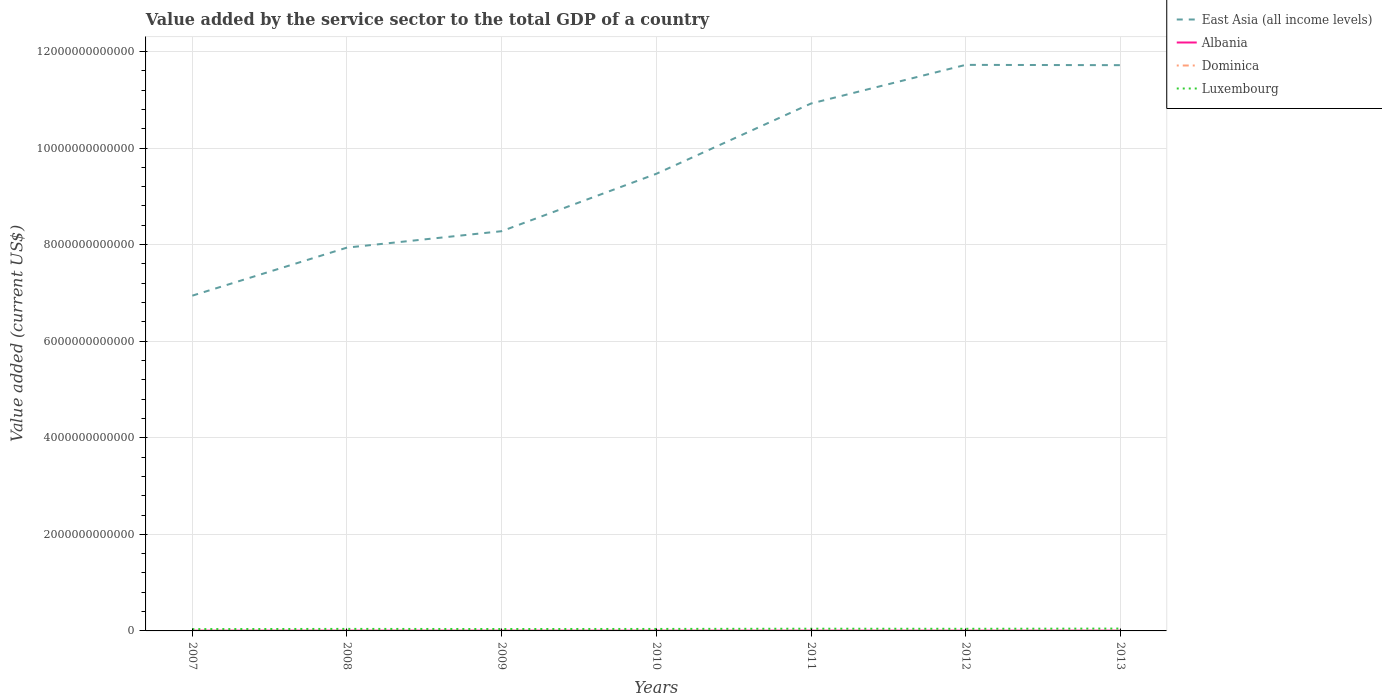Does the line corresponding to East Asia (all income levels) intersect with the line corresponding to Luxembourg?
Give a very brief answer. No. Is the number of lines equal to the number of legend labels?
Keep it short and to the point. Yes. Across all years, what is the maximum value added by the service sector to the total GDP in Dominica?
Offer a terse response. 2.46e+08. What is the total value added by the service sector to the total GDP in Luxembourg in the graph?
Offer a very short reply. -3.57e+09. What is the difference between the highest and the second highest value added by the service sector to the total GDP in Albania?
Offer a terse response. 7.05e+08. What is the difference between the highest and the lowest value added by the service sector to the total GDP in Albania?
Your answer should be very brief. 4. What is the difference between two consecutive major ticks on the Y-axis?
Your answer should be compact. 2.00e+12. How are the legend labels stacked?
Make the answer very short. Vertical. What is the title of the graph?
Provide a succinct answer. Value added by the service sector to the total GDP of a country. Does "St. Kitts and Nevis" appear as one of the legend labels in the graph?
Make the answer very short. No. What is the label or title of the Y-axis?
Ensure brevity in your answer.  Value added (current US$). What is the Value added (current US$) in East Asia (all income levels) in 2007?
Offer a very short reply. 6.94e+12. What is the Value added (current US$) in Albania in 2007?
Offer a terse response. 5.05e+09. What is the Value added (current US$) of Dominica in 2007?
Give a very brief answer. 2.46e+08. What is the Value added (current US$) of Luxembourg in 2007?
Keep it short and to the point. 3.75e+1. What is the Value added (current US$) in East Asia (all income levels) in 2008?
Your response must be concise. 7.94e+12. What is the Value added (current US$) in Albania in 2008?
Give a very brief answer. 5.76e+09. What is the Value added (current US$) of Dominica in 2008?
Keep it short and to the point. 2.65e+08. What is the Value added (current US$) in Luxembourg in 2008?
Keep it short and to the point. 4.19e+1. What is the Value added (current US$) of East Asia (all income levels) in 2009?
Keep it short and to the point. 8.28e+12. What is the Value added (current US$) in Albania in 2009?
Offer a very short reply. 5.46e+09. What is the Value added (current US$) in Dominica in 2009?
Offer a terse response. 2.86e+08. What is the Value added (current US$) of Luxembourg in 2009?
Your answer should be very brief. 3.93e+1. What is the Value added (current US$) of East Asia (all income levels) in 2010?
Your answer should be very brief. 9.47e+12. What is the Value added (current US$) of Albania in 2010?
Your answer should be compact. 5.25e+09. What is the Value added (current US$) of Dominica in 2010?
Provide a short and direct response. 2.93e+08. What is the Value added (current US$) in Luxembourg in 2010?
Your answer should be compact. 4.10e+1. What is the Value added (current US$) in East Asia (all income levels) in 2011?
Ensure brevity in your answer.  1.09e+13. What is the Value added (current US$) in Albania in 2011?
Provide a short and direct response. 5.71e+09. What is the Value added (current US$) of Dominica in 2011?
Your answer should be compact. 2.91e+08. What is the Value added (current US$) in Luxembourg in 2011?
Ensure brevity in your answer.  4.59e+1. What is the Value added (current US$) of East Asia (all income levels) in 2012?
Offer a terse response. 1.17e+13. What is the Value added (current US$) of Albania in 2012?
Ensure brevity in your answer.  5.54e+09. What is the Value added (current US$) in Dominica in 2012?
Offer a terse response. 2.85e+08. What is the Value added (current US$) of Luxembourg in 2012?
Offer a terse response. 4.39e+1. What is the Value added (current US$) of East Asia (all income levels) in 2013?
Provide a succinct answer. 1.17e+13. What is the Value added (current US$) in Albania in 2013?
Your answer should be very brief. 5.70e+09. What is the Value added (current US$) of Dominica in 2013?
Ensure brevity in your answer.  2.97e+08. What is the Value added (current US$) of Luxembourg in 2013?
Provide a succinct answer. 4.88e+1. Across all years, what is the maximum Value added (current US$) in East Asia (all income levels)?
Provide a succinct answer. 1.17e+13. Across all years, what is the maximum Value added (current US$) in Albania?
Offer a very short reply. 5.76e+09. Across all years, what is the maximum Value added (current US$) in Dominica?
Give a very brief answer. 2.97e+08. Across all years, what is the maximum Value added (current US$) of Luxembourg?
Provide a succinct answer. 4.88e+1. Across all years, what is the minimum Value added (current US$) of East Asia (all income levels)?
Provide a short and direct response. 6.94e+12. Across all years, what is the minimum Value added (current US$) in Albania?
Make the answer very short. 5.05e+09. Across all years, what is the minimum Value added (current US$) of Dominica?
Ensure brevity in your answer.  2.46e+08. Across all years, what is the minimum Value added (current US$) of Luxembourg?
Offer a very short reply. 3.75e+1. What is the total Value added (current US$) of East Asia (all income levels) in the graph?
Ensure brevity in your answer.  6.70e+13. What is the total Value added (current US$) of Albania in the graph?
Offer a very short reply. 3.85e+1. What is the total Value added (current US$) of Dominica in the graph?
Keep it short and to the point. 1.96e+09. What is the total Value added (current US$) of Luxembourg in the graph?
Offer a terse response. 2.98e+11. What is the difference between the Value added (current US$) of East Asia (all income levels) in 2007 and that in 2008?
Offer a very short reply. -9.95e+11. What is the difference between the Value added (current US$) in Albania in 2007 and that in 2008?
Your response must be concise. -7.05e+08. What is the difference between the Value added (current US$) in Dominica in 2007 and that in 2008?
Provide a succinct answer. -1.88e+07. What is the difference between the Value added (current US$) of Luxembourg in 2007 and that in 2008?
Offer a terse response. -4.41e+09. What is the difference between the Value added (current US$) in East Asia (all income levels) in 2007 and that in 2009?
Offer a terse response. -1.34e+12. What is the difference between the Value added (current US$) of Albania in 2007 and that in 2009?
Offer a terse response. -4.05e+08. What is the difference between the Value added (current US$) in Dominica in 2007 and that in 2009?
Provide a succinct answer. -4.00e+07. What is the difference between the Value added (current US$) in Luxembourg in 2007 and that in 2009?
Provide a short and direct response. -1.84e+09. What is the difference between the Value added (current US$) of East Asia (all income levels) in 2007 and that in 2010?
Keep it short and to the point. -2.52e+12. What is the difference between the Value added (current US$) of Albania in 2007 and that in 2010?
Your answer should be very brief. -1.98e+08. What is the difference between the Value added (current US$) in Dominica in 2007 and that in 2010?
Keep it short and to the point. -4.67e+07. What is the difference between the Value added (current US$) of Luxembourg in 2007 and that in 2010?
Keep it short and to the point. -3.57e+09. What is the difference between the Value added (current US$) in East Asia (all income levels) in 2007 and that in 2011?
Offer a very short reply. -3.98e+12. What is the difference between the Value added (current US$) of Albania in 2007 and that in 2011?
Make the answer very short. -6.52e+08. What is the difference between the Value added (current US$) of Dominica in 2007 and that in 2011?
Give a very brief answer. -4.49e+07. What is the difference between the Value added (current US$) in Luxembourg in 2007 and that in 2011?
Offer a terse response. -8.43e+09. What is the difference between the Value added (current US$) in East Asia (all income levels) in 2007 and that in 2012?
Provide a short and direct response. -4.78e+12. What is the difference between the Value added (current US$) of Albania in 2007 and that in 2012?
Keep it short and to the point. -4.85e+08. What is the difference between the Value added (current US$) of Dominica in 2007 and that in 2012?
Your answer should be compact. -3.86e+07. What is the difference between the Value added (current US$) of Luxembourg in 2007 and that in 2012?
Ensure brevity in your answer.  -6.42e+09. What is the difference between the Value added (current US$) in East Asia (all income levels) in 2007 and that in 2013?
Offer a very short reply. -4.77e+12. What is the difference between the Value added (current US$) of Albania in 2007 and that in 2013?
Provide a succinct answer. -6.48e+08. What is the difference between the Value added (current US$) in Dominica in 2007 and that in 2013?
Give a very brief answer. -5.06e+07. What is the difference between the Value added (current US$) in Luxembourg in 2007 and that in 2013?
Ensure brevity in your answer.  -1.13e+1. What is the difference between the Value added (current US$) in East Asia (all income levels) in 2008 and that in 2009?
Make the answer very short. -3.40e+11. What is the difference between the Value added (current US$) of Albania in 2008 and that in 2009?
Make the answer very short. 3.00e+08. What is the difference between the Value added (current US$) in Dominica in 2008 and that in 2009?
Your answer should be very brief. -2.11e+07. What is the difference between the Value added (current US$) of Luxembourg in 2008 and that in 2009?
Your answer should be compact. 2.56e+09. What is the difference between the Value added (current US$) in East Asia (all income levels) in 2008 and that in 2010?
Your answer should be compact. -1.53e+12. What is the difference between the Value added (current US$) of Albania in 2008 and that in 2010?
Give a very brief answer. 5.07e+08. What is the difference between the Value added (current US$) in Dominica in 2008 and that in 2010?
Provide a short and direct response. -2.78e+07. What is the difference between the Value added (current US$) in Luxembourg in 2008 and that in 2010?
Give a very brief answer. 8.35e+08. What is the difference between the Value added (current US$) of East Asia (all income levels) in 2008 and that in 2011?
Keep it short and to the point. -2.98e+12. What is the difference between the Value added (current US$) of Albania in 2008 and that in 2011?
Ensure brevity in your answer.  5.28e+07. What is the difference between the Value added (current US$) of Dominica in 2008 and that in 2011?
Offer a very short reply. -2.61e+07. What is the difference between the Value added (current US$) of Luxembourg in 2008 and that in 2011?
Give a very brief answer. -4.02e+09. What is the difference between the Value added (current US$) in East Asia (all income levels) in 2008 and that in 2012?
Keep it short and to the point. -3.78e+12. What is the difference between the Value added (current US$) in Albania in 2008 and that in 2012?
Make the answer very short. 2.20e+08. What is the difference between the Value added (current US$) of Dominica in 2008 and that in 2012?
Your response must be concise. -1.97e+07. What is the difference between the Value added (current US$) in Luxembourg in 2008 and that in 2012?
Your answer should be very brief. -2.01e+09. What is the difference between the Value added (current US$) of East Asia (all income levels) in 2008 and that in 2013?
Your response must be concise. -3.78e+12. What is the difference between the Value added (current US$) in Albania in 2008 and that in 2013?
Ensure brevity in your answer.  5.67e+07. What is the difference between the Value added (current US$) in Dominica in 2008 and that in 2013?
Ensure brevity in your answer.  -3.18e+07. What is the difference between the Value added (current US$) in Luxembourg in 2008 and that in 2013?
Your response must be concise. -6.88e+09. What is the difference between the Value added (current US$) in East Asia (all income levels) in 2009 and that in 2010?
Offer a very short reply. -1.19e+12. What is the difference between the Value added (current US$) in Albania in 2009 and that in 2010?
Your answer should be very brief. 2.07e+08. What is the difference between the Value added (current US$) in Dominica in 2009 and that in 2010?
Offer a terse response. -6.71e+06. What is the difference between the Value added (current US$) of Luxembourg in 2009 and that in 2010?
Provide a short and direct response. -1.73e+09. What is the difference between the Value added (current US$) in East Asia (all income levels) in 2009 and that in 2011?
Your response must be concise. -2.64e+12. What is the difference between the Value added (current US$) of Albania in 2009 and that in 2011?
Offer a terse response. -2.47e+08. What is the difference between the Value added (current US$) of Dominica in 2009 and that in 2011?
Your answer should be very brief. -4.95e+06. What is the difference between the Value added (current US$) of Luxembourg in 2009 and that in 2011?
Provide a succinct answer. -6.58e+09. What is the difference between the Value added (current US$) of East Asia (all income levels) in 2009 and that in 2012?
Ensure brevity in your answer.  -3.44e+12. What is the difference between the Value added (current US$) of Albania in 2009 and that in 2012?
Offer a terse response. -8.02e+07. What is the difference between the Value added (current US$) of Dominica in 2009 and that in 2012?
Offer a very short reply. 1.37e+06. What is the difference between the Value added (current US$) of Luxembourg in 2009 and that in 2012?
Give a very brief answer. -4.57e+09. What is the difference between the Value added (current US$) in East Asia (all income levels) in 2009 and that in 2013?
Provide a succinct answer. -3.44e+12. What is the difference between the Value added (current US$) of Albania in 2009 and that in 2013?
Keep it short and to the point. -2.43e+08. What is the difference between the Value added (current US$) of Dominica in 2009 and that in 2013?
Your answer should be very brief. -1.07e+07. What is the difference between the Value added (current US$) in Luxembourg in 2009 and that in 2013?
Your answer should be very brief. -9.45e+09. What is the difference between the Value added (current US$) of East Asia (all income levels) in 2010 and that in 2011?
Your answer should be very brief. -1.46e+12. What is the difference between the Value added (current US$) in Albania in 2010 and that in 2011?
Ensure brevity in your answer.  -4.54e+08. What is the difference between the Value added (current US$) in Dominica in 2010 and that in 2011?
Ensure brevity in your answer.  1.76e+06. What is the difference between the Value added (current US$) in Luxembourg in 2010 and that in 2011?
Make the answer very short. -4.85e+09. What is the difference between the Value added (current US$) of East Asia (all income levels) in 2010 and that in 2012?
Offer a terse response. -2.26e+12. What is the difference between the Value added (current US$) of Albania in 2010 and that in 2012?
Offer a very short reply. -2.87e+08. What is the difference between the Value added (current US$) of Dominica in 2010 and that in 2012?
Provide a short and direct response. 8.08e+06. What is the difference between the Value added (current US$) of Luxembourg in 2010 and that in 2012?
Your response must be concise. -2.85e+09. What is the difference between the Value added (current US$) in East Asia (all income levels) in 2010 and that in 2013?
Make the answer very short. -2.25e+12. What is the difference between the Value added (current US$) in Albania in 2010 and that in 2013?
Offer a terse response. -4.50e+08. What is the difference between the Value added (current US$) of Dominica in 2010 and that in 2013?
Make the answer very short. -3.98e+06. What is the difference between the Value added (current US$) in Luxembourg in 2010 and that in 2013?
Your answer should be compact. -7.72e+09. What is the difference between the Value added (current US$) in East Asia (all income levels) in 2011 and that in 2012?
Make the answer very short. -8.00e+11. What is the difference between the Value added (current US$) of Albania in 2011 and that in 2012?
Provide a succinct answer. 1.67e+08. What is the difference between the Value added (current US$) of Dominica in 2011 and that in 2012?
Ensure brevity in your answer.  6.32e+06. What is the difference between the Value added (current US$) of Luxembourg in 2011 and that in 2012?
Your answer should be very brief. 2.01e+09. What is the difference between the Value added (current US$) of East Asia (all income levels) in 2011 and that in 2013?
Offer a very short reply. -7.94e+11. What is the difference between the Value added (current US$) of Albania in 2011 and that in 2013?
Your response must be concise. 3.88e+06. What is the difference between the Value added (current US$) in Dominica in 2011 and that in 2013?
Provide a succinct answer. -5.74e+06. What is the difference between the Value added (current US$) of Luxembourg in 2011 and that in 2013?
Keep it short and to the point. -2.86e+09. What is the difference between the Value added (current US$) in East Asia (all income levels) in 2012 and that in 2013?
Offer a very short reply. 5.95e+09. What is the difference between the Value added (current US$) of Albania in 2012 and that in 2013?
Your response must be concise. -1.63e+08. What is the difference between the Value added (current US$) in Dominica in 2012 and that in 2013?
Offer a terse response. -1.21e+07. What is the difference between the Value added (current US$) of Luxembourg in 2012 and that in 2013?
Your response must be concise. -4.87e+09. What is the difference between the Value added (current US$) in East Asia (all income levels) in 2007 and the Value added (current US$) in Albania in 2008?
Provide a short and direct response. 6.94e+12. What is the difference between the Value added (current US$) of East Asia (all income levels) in 2007 and the Value added (current US$) of Dominica in 2008?
Keep it short and to the point. 6.94e+12. What is the difference between the Value added (current US$) of East Asia (all income levels) in 2007 and the Value added (current US$) of Luxembourg in 2008?
Provide a succinct answer. 6.90e+12. What is the difference between the Value added (current US$) in Albania in 2007 and the Value added (current US$) in Dominica in 2008?
Ensure brevity in your answer.  4.79e+09. What is the difference between the Value added (current US$) of Albania in 2007 and the Value added (current US$) of Luxembourg in 2008?
Give a very brief answer. -3.68e+1. What is the difference between the Value added (current US$) in Dominica in 2007 and the Value added (current US$) in Luxembourg in 2008?
Give a very brief answer. -4.16e+1. What is the difference between the Value added (current US$) of East Asia (all income levels) in 2007 and the Value added (current US$) of Albania in 2009?
Keep it short and to the point. 6.94e+12. What is the difference between the Value added (current US$) of East Asia (all income levels) in 2007 and the Value added (current US$) of Dominica in 2009?
Keep it short and to the point. 6.94e+12. What is the difference between the Value added (current US$) in East Asia (all income levels) in 2007 and the Value added (current US$) in Luxembourg in 2009?
Make the answer very short. 6.90e+12. What is the difference between the Value added (current US$) in Albania in 2007 and the Value added (current US$) in Dominica in 2009?
Give a very brief answer. 4.77e+09. What is the difference between the Value added (current US$) in Albania in 2007 and the Value added (current US$) in Luxembourg in 2009?
Give a very brief answer. -3.43e+1. What is the difference between the Value added (current US$) of Dominica in 2007 and the Value added (current US$) of Luxembourg in 2009?
Keep it short and to the point. -3.91e+1. What is the difference between the Value added (current US$) in East Asia (all income levels) in 2007 and the Value added (current US$) in Albania in 2010?
Your answer should be compact. 6.94e+12. What is the difference between the Value added (current US$) in East Asia (all income levels) in 2007 and the Value added (current US$) in Dominica in 2010?
Ensure brevity in your answer.  6.94e+12. What is the difference between the Value added (current US$) of East Asia (all income levels) in 2007 and the Value added (current US$) of Luxembourg in 2010?
Your response must be concise. 6.90e+12. What is the difference between the Value added (current US$) of Albania in 2007 and the Value added (current US$) of Dominica in 2010?
Offer a very short reply. 4.76e+09. What is the difference between the Value added (current US$) in Albania in 2007 and the Value added (current US$) in Luxembourg in 2010?
Provide a succinct answer. -3.60e+1. What is the difference between the Value added (current US$) of Dominica in 2007 and the Value added (current US$) of Luxembourg in 2010?
Your answer should be very brief. -4.08e+1. What is the difference between the Value added (current US$) in East Asia (all income levels) in 2007 and the Value added (current US$) in Albania in 2011?
Ensure brevity in your answer.  6.94e+12. What is the difference between the Value added (current US$) in East Asia (all income levels) in 2007 and the Value added (current US$) in Dominica in 2011?
Ensure brevity in your answer.  6.94e+12. What is the difference between the Value added (current US$) in East Asia (all income levels) in 2007 and the Value added (current US$) in Luxembourg in 2011?
Offer a terse response. 6.90e+12. What is the difference between the Value added (current US$) in Albania in 2007 and the Value added (current US$) in Dominica in 2011?
Make the answer very short. 4.76e+09. What is the difference between the Value added (current US$) in Albania in 2007 and the Value added (current US$) in Luxembourg in 2011?
Your answer should be compact. -4.08e+1. What is the difference between the Value added (current US$) in Dominica in 2007 and the Value added (current US$) in Luxembourg in 2011?
Offer a terse response. -4.56e+1. What is the difference between the Value added (current US$) in East Asia (all income levels) in 2007 and the Value added (current US$) in Albania in 2012?
Keep it short and to the point. 6.94e+12. What is the difference between the Value added (current US$) in East Asia (all income levels) in 2007 and the Value added (current US$) in Dominica in 2012?
Offer a very short reply. 6.94e+12. What is the difference between the Value added (current US$) of East Asia (all income levels) in 2007 and the Value added (current US$) of Luxembourg in 2012?
Provide a short and direct response. 6.90e+12. What is the difference between the Value added (current US$) of Albania in 2007 and the Value added (current US$) of Dominica in 2012?
Your answer should be very brief. 4.77e+09. What is the difference between the Value added (current US$) of Albania in 2007 and the Value added (current US$) of Luxembourg in 2012?
Your answer should be very brief. -3.88e+1. What is the difference between the Value added (current US$) in Dominica in 2007 and the Value added (current US$) in Luxembourg in 2012?
Your answer should be very brief. -4.36e+1. What is the difference between the Value added (current US$) in East Asia (all income levels) in 2007 and the Value added (current US$) in Albania in 2013?
Ensure brevity in your answer.  6.94e+12. What is the difference between the Value added (current US$) of East Asia (all income levels) in 2007 and the Value added (current US$) of Dominica in 2013?
Provide a succinct answer. 6.94e+12. What is the difference between the Value added (current US$) of East Asia (all income levels) in 2007 and the Value added (current US$) of Luxembourg in 2013?
Give a very brief answer. 6.89e+12. What is the difference between the Value added (current US$) of Albania in 2007 and the Value added (current US$) of Dominica in 2013?
Make the answer very short. 4.76e+09. What is the difference between the Value added (current US$) of Albania in 2007 and the Value added (current US$) of Luxembourg in 2013?
Your response must be concise. -4.37e+1. What is the difference between the Value added (current US$) of Dominica in 2007 and the Value added (current US$) of Luxembourg in 2013?
Your answer should be very brief. -4.85e+1. What is the difference between the Value added (current US$) in East Asia (all income levels) in 2008 and the Value added (current US$) in Albania in 2009?
Your response must be concise. 7.93e+12. What is the difference between the Value added (current US$) in East Asia (all income levels) in 2008 and the Value added (current US$) in Dominica in 2009?
Your answer should be compact. 7.94e+12. What is the difference between the Value added (current US$) in East Asia (all income levels) in 2008 and the Value added (current US$) in Luxembourg in 2009?
Your response must be concise. 7.90e+12. What is the difference between the Value added (current US$) of Albania in 2008 and the Value added (current US$) of Dominica in 2009?
Offer a very short reply. 5.47e+09. What is the difference between the Value added (current US$) of Albania in 2008 and the Value added (current US$) of Luxembourg in 2009?
Provide a short and direct response. -3.36e+1. What is the difference between the Value added (current US$) in Dominica in 2008 and the Value added (current US$) in Luxembourg in 2009?
Ensure brevity in your answer.  -3.90e+1. What is the difference between the Value added (current US$) of East Asia (all income levels) in 2008 and the Value added (current US$) of Albania in 2010?
Make the answer very short. 7.93e+12. What is the difference between the Value added (current US$) of East Asia (all income levels) in 2008 and the Value added (current US$) of Dominica in 2010?
Give a very brief answer. 7.94e+12. What is the difference between the Value added (current US$) of East Asia (all income levels) in 2008 and the Value added (current US$) of Luxembourg in 2010?
Ensure brevity in your answer.  7.90e+12. What is the difference between the Value added (current US$) of Albania in 2008 and the Value added (current US$) of Dominica in 2010?
Make the answer very short. 5.47e+09. What is the difference between the Value added (current US$) of Albania in 2008 and the Value added (current US$) of Luxembourg in 2010?
Provide a succinct answer. -3.53e+1. What is the difference between the Value added (current US$) in Dominica in 2008 and the Value added (current US$) in Luxembourg in 2010?
Make the answer very short. -4.08e+1. What is the difference between the Value added (current US$) of East Asia (all income levels) in 2008 and the Value added (current US$) of Albania in 2011?
Keep it short and to the point. 7.93e+12. What is the difference between the Value added (current US$) in East Asia (all income levels) in 2008 and the Value added (current US$) in Dominica in 2011?
Make the answer very short. 7.94e+12. What is the difference between the Value added (current US$) in East Asia (all income levels) in 2008 and the Value added (current US$) in Luxembourg in 2011?
Provide a succinct answer. 7.89e+12. What is the difference between the Value added (current US$) of Albania in 2008 and the Value added (current US$) of Dominica in 2011?
Provide a short and direct response. 5.47e+09. What is the difference between the Value added (current US$) in Albania in 2008 and the Value added (current US$) in Luxembourg in 2011?
Make the answer very short. -4.01e+1. What is the difference between the Value added (current US$) in Dominica in 2008 and the Value added (current US$) in Luxembourg in 2011?
Give a very brief answer. -4.56e+1. What is the difference between the Value added (current US$) of East Asia (all income levels) in 2008 and the Value added (current US$) of Albania in 2012?
Keep it short and to the point. 7.93e+12. What is the difference between the Value added (current US$) in East Asia (all income levels) in 2008 and the Value added (current US$) in Dominica in 2012?
Keep it short and to the point. 7.94e+12. What is the difference between the Value added (current US$) of East Asia (all income levels) in 2008 and the Value added (current US$) of Luxembourg in 2012?
Your answer should be very brief. 7.89e+12. What is the difference between the Value added (current US$) of Albania in 2008 and the Value added (current US$) of Dominica in 2012?
Give a very brief answer. 5.47e+09. What is the difference between the Value added (current US$) in Albania in 2008 and the Value added (current US$) in Luxembourg in 2012?
Make the answer very short. -3.81e+1. What is the difference between the Value added (current US$) in Dominica in 2008 and the Value added (current US$) in Luxembourg in 2012?
Your answer should be compact. -4.36e+1. What is the difference between the Value added (current US$) in East Asia (all income levels) in 2008 and the Value added (current US$) in Albania in 2013?
Offer a very short reply. 7.93e+12. What is the difference between the Value added (current US$) in East Asia (all income levels) in 2008 and the Value added (current US$) in Dominica in 2013?
Your answer should be compact. 7.94e+12. What is the difference between the Value added (current US$) of East Asia (all income levels) in 2008 and the Value added (current US$) of Luxembourg in 2013?
Ensure brevity in your answer.  7.89e+12. What is the difference between the Value added (current US$) of Albania in 2008 and the Value added (current US$) of Dominica in 2013?
Your answer should be very brief. 5.46e+09. What is the difference between the Value added (current US$) in Albania in 2008 and the Value added (current US$) in Luxembourg in 2013?
Provide a succinct answer. -4.30e+1. What is the difference between the Value added (current US$) in Dominica in 2008 and the Value added (current US$) in Luxembourg in 2013?
Keep it short and to the point. -4.85e+1. What is the difference between the Value added (current US$) in East Asia (all income levels) in 2009 and the Value added (current US$) in Albania in 2010?
Keep it short and to the point. 8.27e+12. What is the difference between the Value added (current US$) of East Asia (all income levels) in 2009 and the Value added (current US$) of Dominica in 2010?
Provide a succinct answer. 8.28e+12. What is the difference between the Value added (current US$) in East Asia (all income levels) in 2009 and the Value added (current US$) in Luxembourg in 2010?
Give a very brief answer. 8.24e+12. What is the difference between the Value added (current US$) in Albania in 2009 and the Value added (current US$) in Dominica in 2010?
Make the answer very short. 5.17e+09. What is the difference between the Value added (current US$) in Albania in 2009 and the Value added (current US$) in Luxembourg in 2010?
Offer a terse response. -3.56e+1. What is the difference between the Value added (current US$) of Dominica in 2009 and the Value added (current US$) of Luxembourg in 2010?
Ensure brevity in your answer.  -4.08e+1. What is the difference between the Value added (current US$) in East Asia (all income levels) in 2009 and the Value added (current US$) in Albania in 2011?
Your answer should be compact. 8.27e+12. What is the difference between the Value added (current US$) in East Asia (all income levels) in 2009 and the Value added (current US$) in Dominica in 2011?
Ensure brevity in your answer.  8.28e+12. What is the difference between the Value added (current US$) in East Asia (all income levels) in 2009 and the Value added (current US$) in Luxembourg in 2011?
Make the answer very short. 8.23e+12. What is the difference between the Value added (current US$) in Albania in 2009 and the Value added (current US$) in Dominica in 2011?
Your answer should be very brief. 5.17e+09. What is the difference between the Value added (current US$) in Albania in 2009 and the Value added (current US$) in Luxembourg in 2011?
Provide a succinct answer. -4.04e+1. What is the difference between the Value added (current US$) in Dominica in 2009 and the Value added (current US$) in Luxembourg in 2011?
Your response must be concise. -4.56e+1. What is the difference between the Value added (current US$) of East Asia (all income levels) in 2009 and the Value added (current US$) of Albania in 2012?
Keep it short and to the point. 8.27e+12. What is the difference between the Value added (current US$) of East Asia (all income levels) in 2009 and the Value added (current US$) of Dominica in 2012?
Provide a succinct answer. 8.28e+12. What is the difference between the Value added (current US$) in East Asia (all income levels) in 2009 and the Value added (current US$) in Luxembourg in 2012?
Offer a terse response. 8.23e+12. What is the difference between the Value added (current US$) of Albania in 2009 and the Value added (current US$) of Dominica in 2012?
Your response must be concise. 5.17e+09. What is the difference between the Value added (current US$) of Albania in 2009 and the Value added (current US$) of Luxembourg in 2012?
Provide a succinct answer. -3.84e+1. What is the difference between the Value added (current US$) in Dominica in 2009 and the Value added (current US$) in Luxembourg in 2012?
Offer a very short reply. -4.36e+1. What is the difference between the Value added (current US$) in East Asia (all income levels) in 2009 and the Value added (current US$) in Albania in 2013?
Keep it short and to the point. 8.27e+12. What is the difference between the Value added (current US$) of East Asia (all income levels) in 2009 and the Value added (current US$) of Dominica in 2013?
Offer a terse response. 8.28e+12. What is the difference between the Value added (current US$) of East Asia (all income levels) in 2009 and the Value added (current US$) of Luxembourg in 2013?
Give a very brief answer. 8.23e+12. What is the difference between the Value added (current US$) in Albania in 2009 and the Value added (current US$) in Dominica in 2013?
Make the answer very short. 5.16e+09. What is the difference between the Value added (current US$) in Albania in 2009 and the Value added (current US$) in Luxembourg in 2013?
Your answer should be very brief. -4.33e+1. What is the difference between the Value added (current US$) in Dominica in 2009 and the Value added (current US$) in Luxembourg in 2013?
Provide a short and direct response. -4.85e+1. What is the difference between the Value added (current US$) of East Asia (all income levels) in 2010 and the Value added (current US$) of Albania in 2011?
Make the answer very short. 9.46e+12. What is the difference between the Value added (current US$) of East Asia (all income levels) in 2010 and the Value added (current US$) of Dominica in 2011?
Your answer should be compact. 9.47e+12. What is the difference between the Value added (current US$) of East Asia (all income levels) in 2010 and the Value added (current US$) of Luxembourg in 2011?
Ensure brevity in your answer.  9.42e+12. What is the difference between the Value added (current US$) of Albania in 2010 and the Value added (current US$) of Dominica in 2011?
Offer a very short reply. 4.96e+09. What is the difference between the Value added (current US$) of Albania in 2010 and the Value added (current US$) of Luxembourg in 2011?
Your answer should be compact. -4.06e+1. What is the difference between the Value added (current US$) in Dominica in 2010 and the Value added (current US$) in Luxembourg in 2011?
Offer a terse response. -4.56e+1. What is the difference between the Value added (current US$) in East Asia (all income levels) in 2010 and the Value added (current US$) in Albania in 2012?
Offer a very short reply. 9.46e+12. What is the difference between the Value added (current US$) of East Asia (all income levels) in 2010 and the Value added (current US$) of Dominica in 2012?
Your answer should be very brief. 9.47e+12. What is the difference between the Value added (current US$) in East Asia (all income levels) in 2010 and the Value added (current US$) in Luxembourg in 2012?
Offer a very short reply. 9.42e+12. What is the difference between the Value added (current US$) of Albania in 2010 and the Value added (current US$) of Dominica in 2012?
Ensure brevity in your answer.  4.97e+09. What is the difference between the Value added (current US$) in Albania in 2010 and the Value added (current US$) in Luxembourg in 2012?
Provide a short and direct response. -3.86e+1. What is the difference between the Value added (current US$) of Dominica in 2010 and the Value added (current US$) of Luxembourg in 2012?
Provide a succinct answer. -4.36e+1. What is the difference between the Value added (current US$) of East Asia (all income levels) in 2010 and the Value added (current US$) of Albania in 2013?
Your response must be concise. 9.46e+12. What is the difference between the Value added (current US$) of East Asia (all income levels) in 2010 and the Value added (current US$) of Dominica in 2013?
Provide a succinct answer. 9.47e+12. What is the difference between the Value added (current US$) in East Asia (all income levels) in 2010 and the Value added (current US$) in Luxembourg in 2013?
Make the answer very short. 9.42e+12. What is the difference between the Value added (current US$) of Albania in 2010 and the Value added (current US$) of Dominica in 2013?
Give a very brief answer. 4.95e+09. What is the difference between the Value added (current US$) in Albania in 2010 and the Value added (current US$) in Luxembourg in 2013?
Offer a terse response. -4.35e+1. What is the difference between the Value added (current US$) in Dominica in 2010 and the Value added (current US$) in Luxembourg in 2013?
Your answer should be very brief. -4.85e+1. What is the difference between the Value added (current US$) in East Asia (all income levels) in 2011 and the Value added (current US$) in Albania in 2012?
Offer a very short reply. 1.09e+13. What is the difference between the Value added (current US$) in East Asia (all income levels) in 2011 and the Value added (current US$) in Dominica in 2012?
Your answer should be compact. 1.09e+13. What is the difference between the Value added (current US$) of East Asia (all income levels) in 2011 and the Value added (current US$) of Luxembourg in 2012?
Offer a very short reply. 1.09e+13. What is the difference between the Value added (current US$) in Albania in 2011 and the Value added (current US$) in Dominica in 2012?
Offer a very short reply. 5.42e+09. What is the difference between the Value added (current US$) in Albania in 2011 and the Value added (current US$) in Luxembourg in 2012?
Your response must be concise. -3.82e+1. What is the difference between the Value added (current US$) of Dominica in 2011 and the Value added (current US$) of Luxembourg in 2012?
Your answer should be compact. -4.36e+1. What is the difference between the Value added (current US$) in East Asia (all income levels) in 2011 and the Value added (current US$) in Albania in 2013?
Make the answer very short. 1.09e+13. What is the difference between the Value added (current US$) of East Asia (all income levels) in 2011 and the Value added (current US$) of Dominica in 2013?
Your response must be concise. 1.09e+13. What is the difference between the Value added (current US$) of East Asia (all income levels) in 2011 and the Value added (current US$) of Luxembourg in 2013?
Your answer should be very brief. 1.09e+13. What is the difference between the Value added (current US$) in Albania in 2011 and the Value added (current US$) in Dominica in 2013?
Provide a short and direct response. 5.41e+09. What is the difference between the Value added (current US$) in Albania in 2011 and the Value added (current US$) in Luxembourg in 2013?
Your response must be concise. -4.31e+1. What is the difference between the Value added (current US$) of Dominica in 2011 and the Value added (current US$) of Luxembourg in 2013?
Offer a terse response. -4.85e+1. What is the difference between the Value added (current US$) in East Asia (all income levels) in 2012 and the Value added (current US$) in Albania in 2013?
Make the answer very short. 1.17e+13. What is the difference between the Value added (current US$) in East Asia (all income levels) in 2012 and the Value added (current US$) in Dominica in 2013?
Keep it short and to the point. 1.17e+13. What is the difference between the Value added (current US$) of East Asia (all income levels) in 2012 and the Value added (current US$) of Luxembourg in 2013?
Your answer should be very brief. 1.17e+13. What is the difference between the Value added (current US$) in Albania in 2012 and the Value added (current US$) in Dominica in 2013?
Offer a terse response. 5.24e+09. What is the difference between the Value added (current US$) in Albania in 2012 and the Value added (current US$) in Luxembourg in 2013?
Your response must be concise. -4.32e+1. What is the difference between the Value added (current US$) of Dominica in 2012 and the Value added (current US$) of Luxembourg in 2013?
Ensure brevity in your answer.  -4.85e+1. What is the average Value added (current US$) of East Asia (all income levels) per year?
Give a very brief answer. 9.57e+12. What is the average Value added (current US$) of Albania per year?
Give a very brief answer. 5.49e+09. What is the average Value added (current US$) in Dominica per year?
Ensure brevity in your answer.  2.80e+08. What is the average Value added (current US$) in Luxembourg per year?
Provide a succinct answer. 4.26e+1. In the year 2007, what is the difference between the Value added (current US$) in East Asia (all income levels) and Value added (current US$) in Albania?
Provide a short and direct response. 6.94e+12. In the year 2007, what is the difference between the Value added (current US$) in East Asia (all income levels) and Value added (current US$) in Dominica?
Your answer should be very brief. 6.94e+12. In the year 2007, what is the difference between the Value added (current US$) in East Asia (all income levels) and Value added (current US$) in Luxembourg?
Keep it short and to the point. 6.91e+12. In the year 2007, what is the difference between the Value added (current US$) of Albania and Value added (current US$) of Dominica?
Offer a very short reply. 4.81e+09. In the year 2007, what is the difference between the Value added (current US$) in Albania and Value added (current US$) in Luxembourg?
Provide a short and direct response. -3.24e+1. In the year 2007, what is the difference between the Value added (current US$) in Dominica and Value added (current US$) in Luxembourg?
Your answer should be compact. -3.72e+1. In the year 2008, what is the difference between the Value added (current US$) in East Asia (all income levels) and Value added (current US$) in Albania?
Give a very brief answer. 7.93e+12. In the year 2008, what is the difference between the Value added (current US$) of East Asia (all income levels) and Value added (current US$) of Dominica?
Keep it short and to the point. 7.94e+12. In the year 2008, what is the difference between the Value added (current US$) in East Asia (all income levels) and Value added (current US$) in Luxembourg?
Offer a terse response. 7.90e+12. In the year 2008, what is the difference between the Value added (current US$) of Albania and Value added (current US$) of Dominica?
Keep it short and to the point. 5.49e+09. In the year 2008, what is the difference between the Value added (current US$) of Albania and Value added (current US$) of Luxembourg?
Offer a very short reply. -3.61e+1. In the year 2008, what is the difference between the Value added (current US$) in Dominica and Value added (current US$) in Luxembourg?
Your response must be concise. -4.16e+1. In the year 2009, what is the difference between the Value added (current US$) in East Asia (all income levels) and Value added (current US$) in Albania?
Provide a short and direct response. 8.27e+12. In the year 2009, what is the difference between the Value added (current US$) of East Asia (all income levels) and Value added (current US$) of Dominica?
Give a very brief answer. 8.28e+12. In the year 2009, what is the difference between the Value added (current US$) of East Asia (all income levels) and Value added (current US$) of Luxembourg?
Your answer should be very brief. 8.24e+12. In the year 2009, what is the difference between the Value added (current US$) of Albania and Value added (current US$) of Dominica?
Give a very brief answer. 5.17e+09. In the year 2009, what is the difference between the Value added (current US$) in Albania and Value added (current US$) in Luxembourg?
Keep it short and to the point. -3.39e+1. In the year 2009, what is the difference between the Value added (current US$) in Dominica and Value added (current US$) in Luxembourg?
Provide a succinct answer. -3.90e+1. In the year 2010, what is the difference between the Value added (current US$) of East Asia (all income levels) and Value added (current US$) of Albania?
Your response must be concise. 9.46e+12. In the year 2010, what is the difference between the Value added (current US$) in East Asia (all income levels) and Value added (current US$) in Dominica?
Keep it short and to the point. 9.47e+12. In the year 2010, what is the difference between the Value added (current US$) in East Asia (all income levels) and Value added (current US$) in Luxembourg?
Offer a very short reply. 9.43e+12. In the year 2010, what is the difference between the Value added (current US$) in Albania and Value added (current US$) in Dominica?
Give a very brief answer. 4.96e+09. In the year 2010, what is the difference between the Value added (current US$) in Albania and Value added (current US$) in Luxembourg?
Keep it short and to the point. -3.58e+1. In the year 2010, what is the difference between the Value added (current US$) of Dominica and Value added (current US$) of Luxembourg?
Make the answer very short. -4.07e+1. In the year 2011, what is the difference between the Value added (current US$) of East Asia (all income levels) and Value added (current US$) of Albania?
Provide a short and direct response. 1.09e+13. In the year 2011, what is the difference between the Value added (current US$) in East Asia (all income levels) and Value added (current US$) in Dominica?
Your answer should be compact. 1.09e+13. In the year 2011, what is the difference between the Value added (current US$) of East Asia (all income levels) and Value added (current US$) of Luxembourg?
Ensure brevity in your answer.  1.09e+13. In the year 2011, what is the difference between the Value added (current US$) in Albania and Value added (current US$) in Dominica?
Offer a very short reply. 5.41e+09. In the year 2011, what is the difference between the Value added (current US$) in Albania and Value added (current US$) in Luxembourg?
Your answer should be very brief. -4.02e+1. In the year 2011, what is the difference between the Value added (current US$) of Dominica and Value added (current US$) of Luxembourg?
Make the answer very short. -4.56e+1. In the year 2012, what is the difference between the Value added (current US$) of East Asia (all income levels) and Value added (current US$) of Albania?
Offer a very short reply. 1.17e+13. In the year 2012, what is the difference between the Value added (current US$) in East Asia (all income levels) and Value added (current US$) in Dominica?
Make the answer very short. 1.17e+13. In the year 2012, what is the difference between the Value added (current US$) of East Asia (all income levels) and Value added (current US$) of Luxembourg?
Offer a terse response. 1.17e+13. In the year 2012, what is the difference between the Value added (current US$) in Albania and Value added (current US$) in Dominica?
Your response must be concise. 5.25e+09. In the year 2012, what is the difference between the Value added (current US$) of Albania and Value added (current US$) of Luxembourg?
Ensure brevity in your answer.  -3.83e+1. In the year 2012, what is the difference between the Value added (current US$) of Dominica and Value added (current US$) of Luxembourg?
Your answer should be very brief. -4.36e+1. In the year 2013, what is the difference between the Value added (current US$) of East Asia (all income levels) and Value added (current US$) of Albania?
Make the answer very short. 1.17e+13. In the year 2013, what is the difference between the Value added (current US$) in East Asia (all income levels) and Value added (current US$) in Dominica?
Offer a very short reply. 1.17e+13. In the year 2013, what is the difference between the Value added (current US$) of East Asia (all income levels) and Value added (current US$) of Luxembourg?
Provide a succinct answer. 1.17e+13. In the year 2013, what is the difference between the Value added (current US$) in Albania and Value added (current US$) in Dominica?
Provide a succinct answer. 5.40e+09. In the year 2013, what is the difference between the Value added (current US$) in Albania and Value added (current US$) in Luxembourg?
Offer a terse response. -4.31e+1. In the year 2013, what is the difference between the Value added (current US$) in Dominica and Value added (current US$) in Luxembourg?
Provide a succinct answer. -4.85e+1. What is the ratio of the Value added (current US$) in East Asia (all income levels) in 2007 to that in 2008?
Provide a succinct answer. 0.87. What is the ratio of the Value added (current US$) in Albania in 2007 to that in 2008?
Your response must be concise. 0.88. What is the ratio of the Value added (current US$) of Dominica in 2007 to that in 2008?
Your response must be concise. 0.93. What is the ratio of the Value added (current US$) in Luxembourg in 2007 to that in 2008?
Your answer should be compact. 0.89. What is the ratio of the Value added (current US$) in East Asia (all income levels) in 2007 to that in 2009?
Offer a terse response. 0.84. What is the ratio of the Value added (current US$) of Albania in 2007 to that in 2009?
Provide a succinct answer. 0.93. What is the ratio of the Value added (current US$) of Dominica in 2007 to that in 2009?
Make the answer very short. 0.86. What is the ratio of the Value added (current US$) in Luxembourg in 2007 to that in 2009?
Your response must be concise. 0.95. What is the ratio of the Value added (current US$) of East Asia (all income levels) in 2007 to that in 2010?
Provide a succinct answer. 0.73. What is the ratio of the Value added (current US$) of Albania in 2007 to that in 2010?
Offer a terse response. 0.96. What is the ratio of the Value added (current US$) in Dominica in 2007 to that in 2010?
Your response must be concise. 0.84. What is the ratio of the Value added (current US$) in East Asia (all income levels) in 2007 to that in 2011?
Your answer should be very brief. 0.64. What is the ratio of the Value added (current US$) of Albania in 2007 to that in 2011?
Offer a terse response. 0.89. What is the ratio of the Value added (current US$) of Dominica in 2007 to that in 2011?
Ensure brevity in your answer.  0.85. What is the ratio of the Value added (current US$) in Luxembourg in 2007 to that in 2011?
Your answer should be very brief. 0.82. What is the ratio of the Value added (current US$) of East Asia (all income levels) in 2007 to that in 2012?
Offer a terse response. 0.59. What is the ratio of the Value added (current US$) of Albania in 2007 to that in 2012?
Ensure brevity in your answer.  0.91. What is the ratio of the Value added (current US$) in Dominica in 2007 to that in 2012?
Offer a terse response. 0.86. What is the ratio of the Value added (current US$) of Luxembourg in 2007 to that in 2012?
Keep it short and to the point. 0.85. What is the ratio of the Value added (current US$) in East Asia (all income levels) in 2007 to that in 2013?
Provide a succinct answer. 0.59. What is the ratio of the Value added (current US$) of Albania in 2007 to that in 2013?
Provide a short and direct response. 0.89. What is the ratio of the Value added (current US$) in Dominica in 2007 to that in 2013?
Offer a terse response. 0.83. What is the ratio of the Value added (current US$) of Luxembourg in 2007 to that in 2013?
Offer a very short reply. 0.77. What is the ratio of the Value added (current US$) in East Asia (all income levels) in 2008 to that in 2009?
Your answer should be compact. 0.96. What is the ratio of the Value added (current US$) in Albania in 2008 to that in 2009?
Provide a succinct answer. 1.05. What is the ratio of the Value added (current US$) in Dominica in 2008 to that in 2009?
Make the answer very short. 0.93. What is the ratio of the Value added (current US$) of Luxembourg in 2008 to that in 2009?
Your answer should be very brief. 1.07. What is the ratio of the Value added (current US$) in East Asia (all income levels) in 2008 to that in 2010?
Offer a terse response. 0.84. What is the ratio of the Value added (current US$) of Albania in 2008 to that in 2010?
Ensure brevity in your answer.  1.1. What is the ratio of the Value added (current US$) of Dominica in 2008 to that in 2010?
Provide a short and direct response. 0.91. What is the ratio of the Value added (current US$) of Luxembourg in 2008 to that in 2010?
Ensure brevity in your answer.  1.02. What is the ratio of the Value added (current US$) in East Asia (all income levels) in 2008 to that in 2011?
Offer a terse response. 0.73. What is the ratio of the Value added (current US$) of Albania in 2008 to that in 2011?
Your response must be concise. 1.01. What is the ratio of the Value added (current US$) in Dominica in 2008 to that in 2011?
Your answer should be compact. 0.91. What is the ratio of the Value added (current US$) in Luxembourg in 2008 to that in 2011?
Offer a terse response. 0.91. What is the ratio of the Value added (current US$) in East Asia (all income levels) in 2008 to that in 2012?
Make the answer very short. 0.68. What is the ratio of the Value added (current US$) of Albania in 2008 to that in 2012?
Provide a succinct answer. 1.04. What is the ratio of the Value added (current US$) of Dominica in 2008 to that in 2012?
Ensure brevity in your answer.  0.93. What is the ratio of the Value added (current US$) in Luxembourg in 2008 to that in 2012?
Give a very brief answer. 0.95. What is the ratio of the Value added (current US$) in East Asia (all income levels) in 2008 to that in 2013?
Keep it short and to the point. 0.68. What is the ratio of the Value added (current US$) in Albania in 2008 to that in 2013?
Ensure brevity in your answer.  1.01. What is the ratio of the Value added (current US$) in Dominica in 2008 to that in 2013?
Make the answer very short. 0.89. What is the ratio of the Value added (current US$) of Luxembourg in 2008 to that in 2013?
Provide a succinct answer. 0.86. What is the ratio of the Value added (current US$) in East Asia (all income levels) in 2009 to that in 2010?
Your response must be concise. 0.87. What is the ratio of the Value added (current US$) of Albania in 2009 to that in 2010?
Make the answer very short. 1.04. What is the ratio of the Value added (current US$) of Dominica in 2009 to that in 2010?
Ensure brevity in your answer.  0.98. What is the ratio of the Value added (current US$) in Luxembourg in 2009 to that in 2010?
Your answer should be very brief. 0.96. What is the ratio of the Value added (current US$) in East Asia (all income levels) in 2009 to that in 2011?
Keep it short and to the point. 0.76. What is the ratio of the Value added (current US$) of Albania in 2009 to that in 2011?
Provide a succinct answer. 0.96. What is the ratio of the Value added (current US$) of Luxembourg in 2009 to that in 2011?
Ensure brevity in your answer.  0.86. What is the ratio of the Value added (current US$) of East Asia (all income levels) in 2009 to that in 2012?
Your response must be concise. 0.71. What is the ratio of the Value added (current US$) of Albania in 2009 to that in 2012?
Ensure brevity in your answer.  0.99. What is the ratio of the Value added (current US$) in Luxembourg in 2009 to that in 2012?
Your answer should be very brief. 0.9. What is the ratio of the Value added (current US$) of East Asia (all income levels) in 2009 to that in 2013?
Your answer should be very brief. 0.71. What is the ratio of the Value added (current US$) in Albania in 2009 to that in 2013?
Your answer should be very brief. 0.96. What is the ratio of the Value added (current US$) in Dominica in 2009 to that in 2013?
Ensure brevity in your answer.  0.96. What is the ratio of the Value added (current US$) in Luxembourg in 2009 to that in 2013?
Your response must be concise. 0.81. What is the ratio of the Value added (current US$) in East Asia (all income levels) in 2010 to that in 2011?
Provide a succinct answer. 0.87. What is the ratio of the Value added (current US$) in Albania in 2010 to that in 2011?
Give a very brief answer. 0.92. What is the ratio of the Value added (current US$) in Luxembourg in 2010 to that in 2011?
Make the answer very short. 0.89. What is the ratio of the Value added (current US$) of East Asia (all income levels) in 2010 to that in 2012?
Your response must be concise. 0.81. What is the ratio of the Value added (current US$) of Albania in 2010 to that in 2012?
Provide a succinct answer. 0.95. What is the ratio of the Value added (current US$) of Dominica in 2010 to that in 2012?
Give a very brief answer. 1.03. What is the ratio of the Value added (current US$) of Luxembourg in 2010 to that in 2012?
Your answer should be compact. 0.94. What is the ratio of the Value added (current US$) in East Asia (all income levels) in 2010 to that in 2013?
Give a very brief answer. 0.81. What is the ratio of the Value added (current US$) in Albania in 2010 to that in 2013?
Keep it short and to the point. 0.92. What is the ratio of the Value added (current US$) of Dominica in 2010 to that in 2013?
Keep it short and to the point. 0.99. What is the ratio of the Value added (current US$) of Luxembourg in 2010 to that in 2013?
Keep it short and to the point. 0.84. What is the ratio of the Value added (current US$) in East Asia (all income levels) in 2011 to that in 2012?
Provide a short and direct response. 0.93. What is the ratio of the Value added (current US$) in Albania in 2011 to that in 2012?
Provide a succinct answer. 1.03. What is the ratio of the Value added (current US$) of Dominica in 2011 to that in 2012?
Give a very brief answer. 1.02. What is the ratio of the Value added (current US$) in Luxembourg in 2011 to that in 2012?
Make the answer very short. 1.05. What is the ratio of the Value added (current US$) in East Asia (all income levels) in 2011 to that in 2013?
Provide a succinct answer. 0.93. What is the ratio of the Value added (current US$) of Dominica in 2011 to that in 2013?
Provide a short and direct response. 0.98. What is the ratio of the Value added (current US$) in East Asia (all income levels) in 2012 to that in 2013?
Provide a succinct answer. 1. What is the ratio of the Value added (current US$) in Albania in 2012 to that in 2013?
Offer a terse response. 0.97. What is the ratio of the Value added (current US$) of Dominica in 2012 to that in 2013?
Provide a short and direct response. 0.96. What is the ratio of the Value added (current US$) in Luxembourg in 2012 to that in 2013?
Make the answer very short. 0.9. What is the difference between the highest and the second highest Value added (current US$) in East Asia (all income levels)?
Provide a short and direct response. 5.95e+09. What is the difference between the highest and the second highest Value added (current US$) of Albania?
Your answer should be very brief. 5.28e+07. What is the difference between the highest and the second highest Value added (current US$) of Dominica?
Ensure brevity in your answer.  3.98e+06. What is the difference between the highest and the second highest Value added (current US$) of Luxembourg?
Make the answer very short. 2.86e+09. What is the difference between the highest and the lowest Value added (current US$) in East Asia (all income levels)?
Your answer should be compact. 4.78e+12. What is the difference between the highest and the lowest Value added (current US$) in Albania?
Offer a terse response. 7.05e+08. What is the difference between the highest and the lowest Value added (current US$) in Dominica?
Offer a terse response. 5.06e+07. What is the difference between the highest and the lowest Value added (current US$) of Luxembourg?
Give a very brief answer. 1.13e+1. 